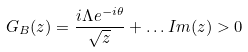Convert formula to latex. <formula><loc_0><loc_0><loc_500><loc_500>G _ { B } ( z ) = \frac { i \Lambda e ^ { - i \theta } } { \sqrt { z } } + \dots I m ( z ) > 0</formula> 